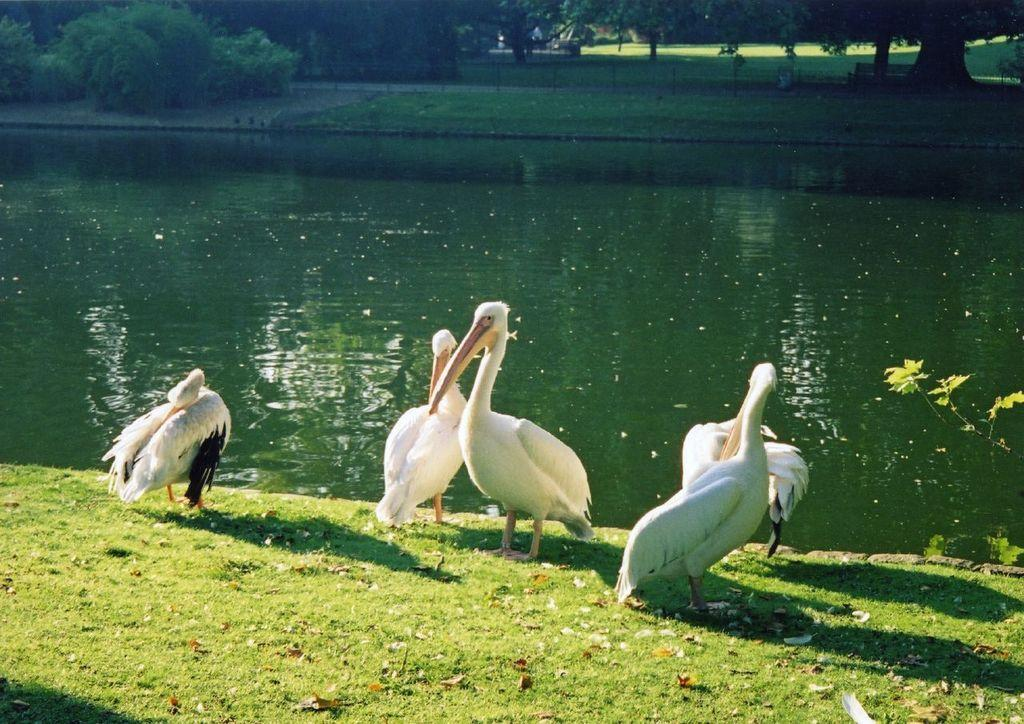What animals can be seen on the ground in the image? There are birds on the ground in the image. What can be seen in the distance behind the birds? There is water visible in the background of the image. What type of vegetation is present in the background of the image? There are trees present in the background of the image. How many sheep are visible in the image? There are no sheep present in the image. What type of appliance can be seen in the image? There is no appliance present in the image. 